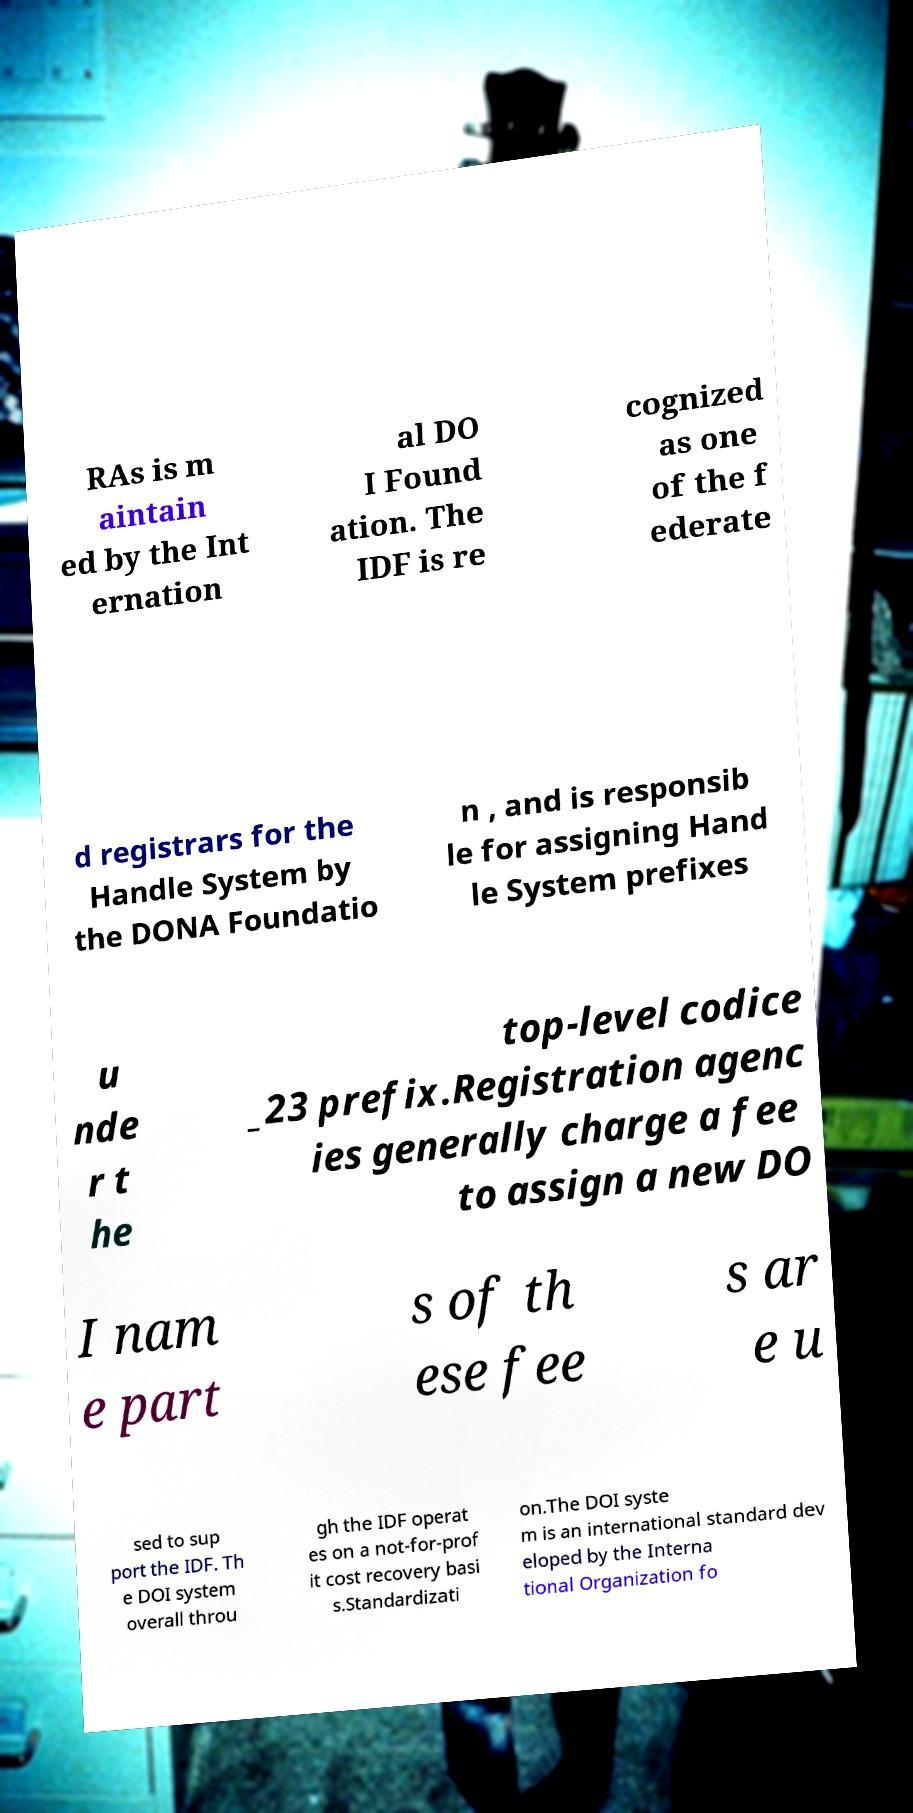Please read and relay the text visible in this image. What does it say? RAs is m aintain ed by the Int ernation al DO I Found ation. The IDF is re cognized as one of the f ederate d registrars for the Handle System by the DONA Foundatio n , and is responsib le for assigning Hand le System prefixes u nde r t he top-level codice _23 prefix.Registration agenc ies generally charge a fee to assign a new DO I nam e part s of th ese fee s ar e u sed to sup port the IDF. Th e DOI system overall throu gh the IDF operat es on a not-for-prof it cost recovery basi s.Standardizati on.The DOI syste m is an international standard dev eloped by the Interna tional Organization fo 